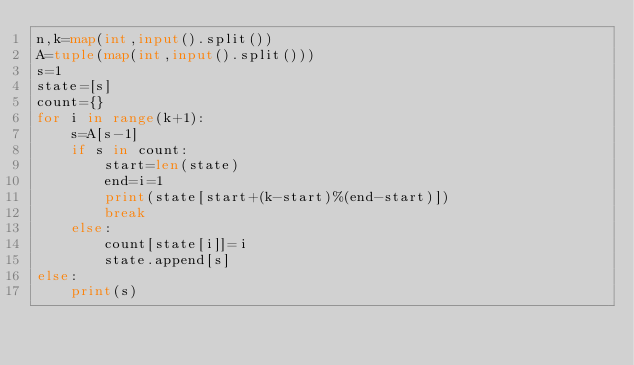<code> <loc_0><loc_0><loc_500><loc_500><_Python_>n,k=map(int,input().split())
A=tuple(map(int,input().split()))
s=1
state=[s]
count={}
for i in range(k+1):
    s=A[s-1]
    if s in count:
        start=len(state)
        end=i=1
        print(state[start+(k-start)%(end-start)])
        break
    else:
        count[state[i]]=i
        state.append[s]
else:
    print(s)
</code> 